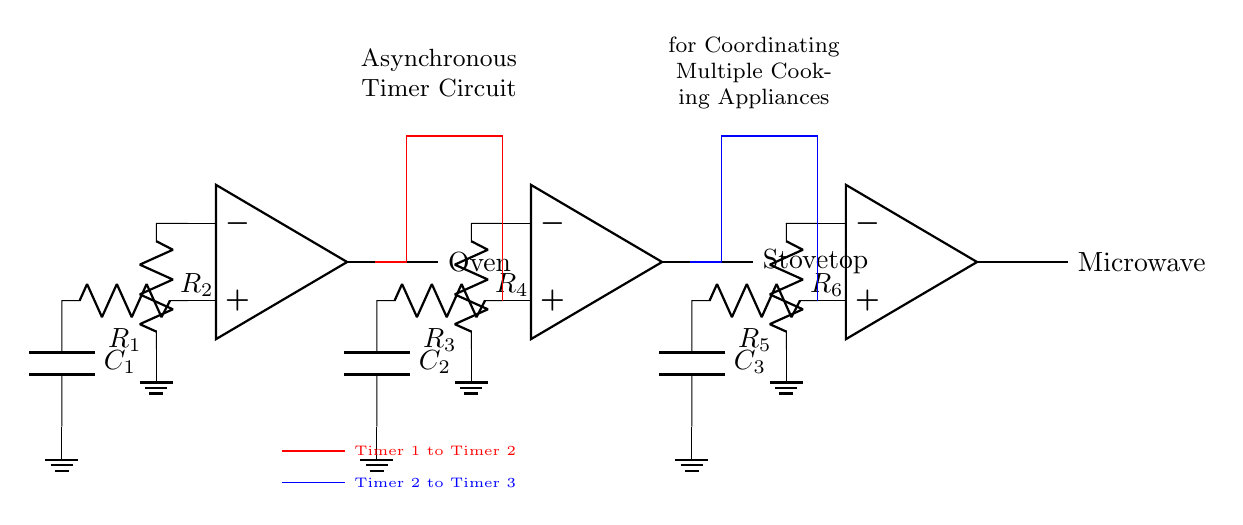What components are present in the circuit? The circuit contains three operational amplifiers, six resistors, and three capacitors. The op-amps serve as the core element of the timer, while the resistors and capacitors determine the timing characteristics.
Answer: Three operational amplifiers, six resistors, three capacitors What is the purpose of the red connection in the diagram? The red connection transfers the output of Timer 1 to Timer 2, indicating a sequential control between the two timers where the completion of Timer 1 triggers Timer 2.
Answer: Timer 1 to Timer 2 How many timers are shown in the circuit? There are three timers depicted in the diagram, each represented by an operational amplifier and connected circuitry. Each timer is responsible for controlling the operation of a different cooking appliance.
Answer: Three What appliances are associated with the outputs of the timers? The output of Timer 1 is connected to the Oven, Timer 2 to the Stovetop, and Timer 3 to the Microwave, allowing for coordinated operation amongst these appliances.
Answer: Oven, Stovetop, Microwave What is the role of resistors in the timer circuit? Resistors are crucial for determining the charge and discharge times of the capacitors, which in turn control the timing intervals for each appliance's operation. The values of the resistors affect the overall timing behavior of the circuit.
Answer: Timing intervals What is the significance of the blue connection in the diagram? The blue connection carries the output from Timer 2 to Timer 3, establishing another sequential control where Timer 3 will only activate after Timer 2 has completed its cycle, ensuring a proper sequence in operation.
Answer: Timer 2 to Timer 3 What type of circuit is represented here? This is an asynchronous timer circuit. It is designed to coordinate the operation of multiple cooking appliances without requiring synchronized starting times, based on independent timing intervals for each appliance.
Answer: Asynchronous timer circuit 